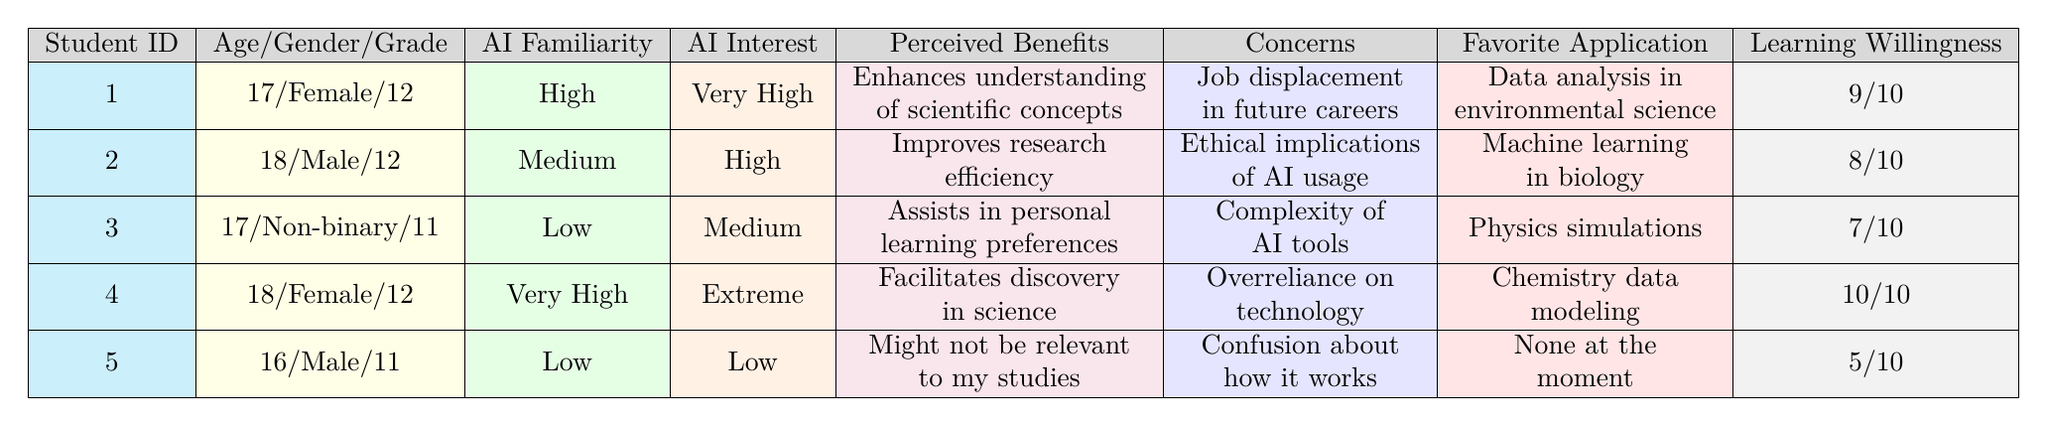What is the highest willingness to learn score among the students? The table shows willingness to learn scores for each student: 9, 8, 7, 10, and 5. The highest score is 10, which belongs to student 4.
Answer: 10 How many students have a high interest in AI? Reviewing the interest in AI column: two students (student 1 and student 2) report "Very High" and "High," respectively. Thus, there are 2 students with high interest.
Answer: 2 What age group has the highest representation in this survey? There are two students aged 18, two students aged 17, and one student aged 16. The highest representation in the survey is the age group 18.
Answer: 18 Are there any students who perceive the benefits of AI as "Might not be relevant to my studies"? Looking at the perceived benefits column, only student 5 states this phrase, indicating there is one student with that perception.
Answer: Yes What is the average willingness to learn score for all students? The willingness scores are 9, 8, 7, 10, and 5. To find the average, sum the scores (39) and divide by the number of students (5): 39/5 = 7.8.
Answer: 7.8 Which student has the lowest familiarity with AI? Student 5 has a "Low" familiarity with AI compared to the others. Student 3 also has "Low," but a closer look indicates that student 5 is the only one reporting the lowest interest level of "Low."
Answer: Student 5 What are the main concerns related to AI for students with high or very high interest? Students with high or very high interest (students 1, 2, and 4) express concerns about job displacement, ethical implications, and overreliance on technology. Hence, common concerns include job-related issues and ethical concerns surrounding AI usage.
Answer: Job displacement, ethical implications, overreliance on technology Do any students mention data analysis or research efficiency as their favorite application of AI? Students 1 (data analysis in environmental science) and 2 (machine learning in biology) mention data-related applications, indicating at least two students refer to this area.
Answer: Yes What percentage of students are familiar with AI at a high level? The table shows 2 out of 5 students (students 1 and 4) have "High" or "Very High" familiarity, resulting in (2/5) * 100 = 40%.
Answer: 40% How many students are willing to learn with a score greater than 7? The willingness scores of students show that students 1 (9), 2 (8), and 4 (10) have scores above 7, totaling 3 students.
Answer: 3 What is the most common preferred resource for learning about AI among these students? Student 1 prefers online courses and hands-on projects, student 2 prefers webinars and interactive simulations, student 3 prefers books and tutorials, student 4 favors research projects and peer mentorship, and student 5 likes simple videos and infographics. Each student has a different preference, with no most common resource identified.
Answer: None (no common resource) 